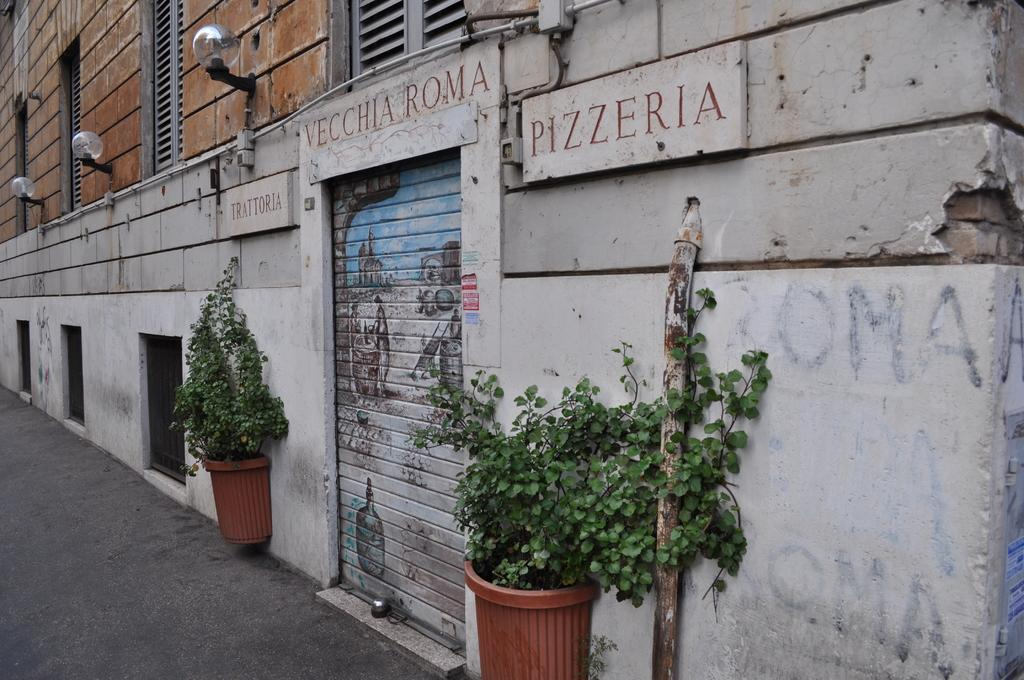What objects are located at the front of the image? There are plant pots in the front of the image. What type of business is located beside the plant pots? There is a roller shutter shop beside the plant pots. What color is the wall visible in the image? There is a brown color wall visible in the image. What type of lighting is present on the brown color wall? Hanging lights are present on the brown color wall. Can you see any chickens playing in the street in the image? There are no chickens or streets present in the image. 